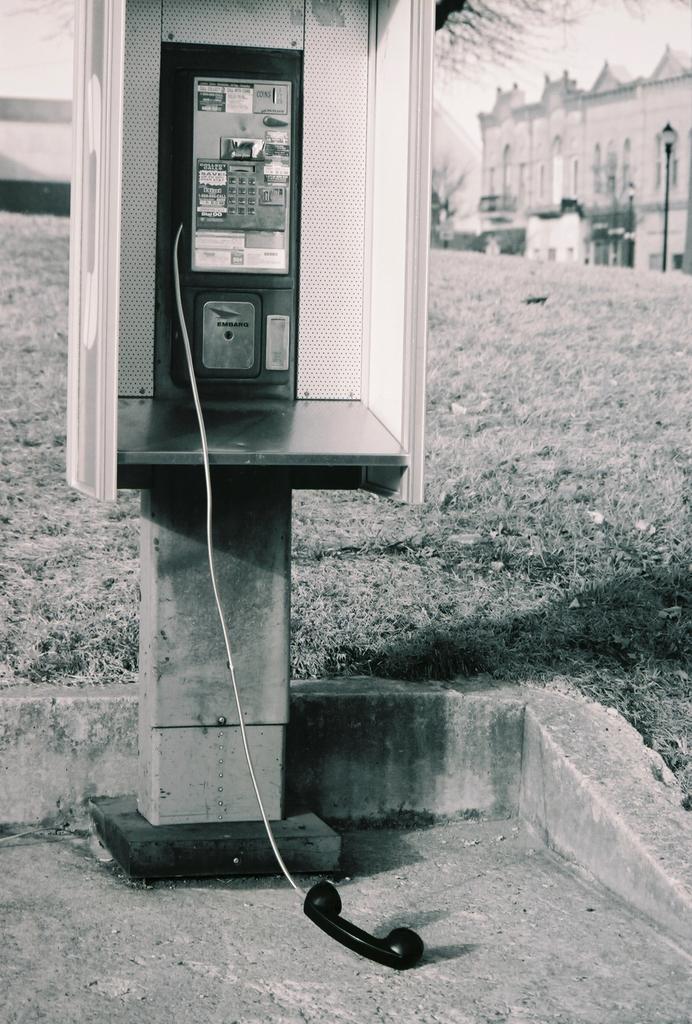Could you give a brief overview of what you see in this image? Black and white picture. Here we can see a telephone. Far there is a building and light pole. 